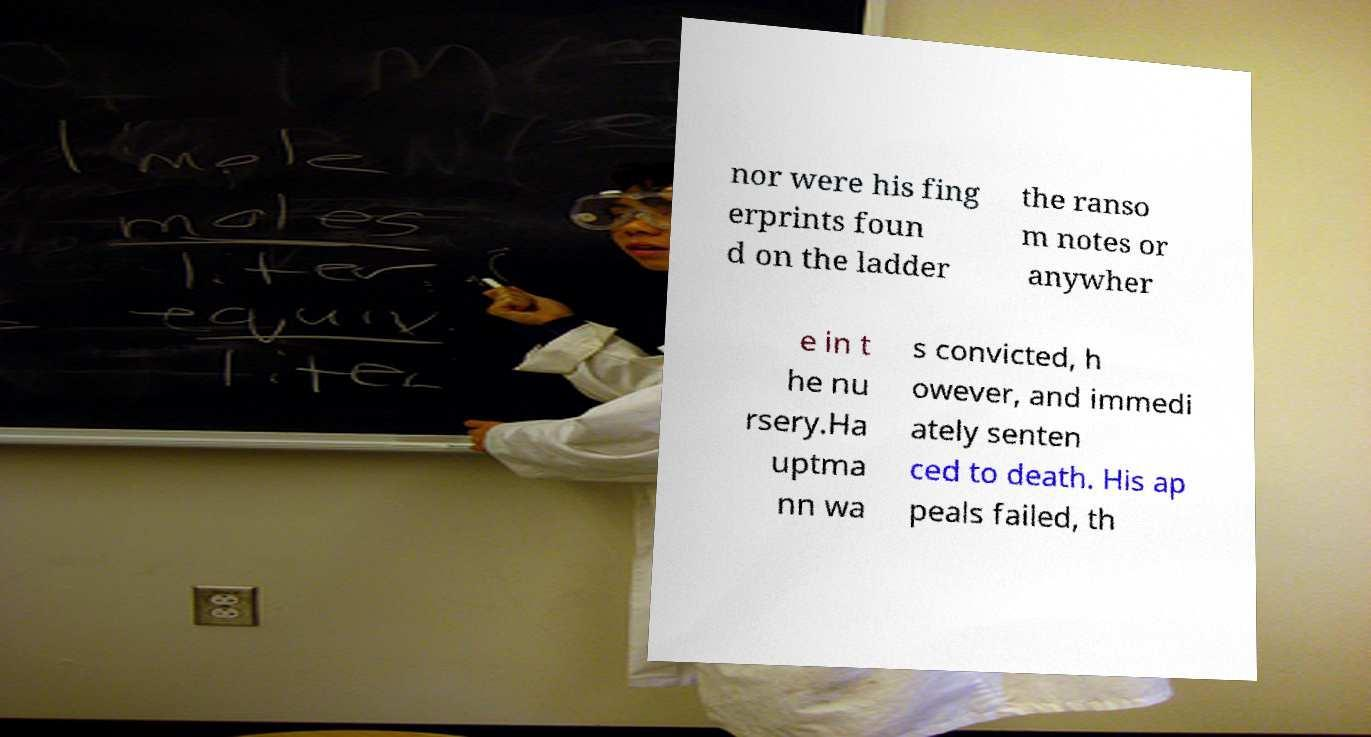What messages or text are displayed in this image? I need them in a readable, typed format. nor were his fing erprints foun d on the ladder the ranso m notes or anywher e in t he nu rsery.Ha uptma nn wa s convicted, h owever, and immedi ately senten ced to death. His ap peals failed, th 